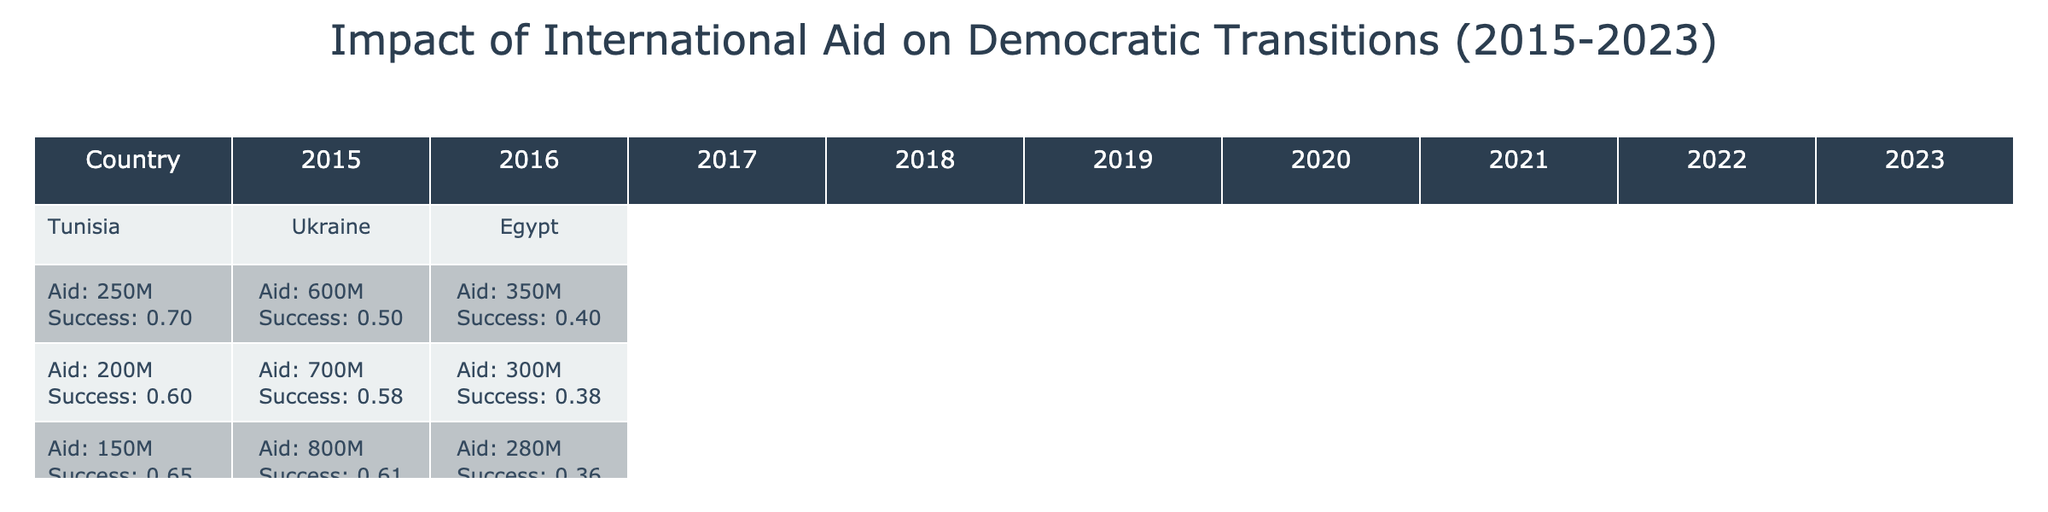What was the highest amount of international aid received by Tunisia between 2015 and 2023? In the table, looking at Tunisia's data, the highest amount of international aid was in 2021 with 350 million USD.
Answer: 350 million USD What was the Democratic Transition Success Index for Ukraine in 2022? The table shows that Ukraine's Democratic Transition Success Index for 2022 is 0.82.
Answer: 0.82 Did Egypt receive more international aid in 2015 than in 2022? From the table, Egypt received 350 million USD in 2015 and 150 million USD in 2022. Since 350 million is greater than 150 million, the answer is yes.
Answer: Yes Which country had the lowest Democratic Transition Success Index in 2019? Comparing the values for 2019, Tunisia has an index of 0.80, Ukraine has 0.67, and Egypt has 0.37. The country with the lowest index is Egypt at 0.37.
Answer: Egypt What is the total international aid received by Ukraine from 2015 to 2023? We can sum the international aid values for Ukraine from each year: 600 + 700 + 800 + 750 + 900 + 1000 + 1100 + 1200 + 1300 = 7050 million USD.
Answer: 7050 million USD How did the Democratic Transition Success Index for Egypt change from 2015 to 2023? In 2015, Egypt's index was 0.40, dropping to 0.28 in 2023. The change indicates a decline over the years.
Answer: Declined Was there a year where Tunisia had both the highest international aid and the highest success index? The highest international aid for Tunisia was in 2021 (350 million USD) with a success index of 0.81. Therefore, 2021 does not have the highest index, which was 0.85 in 2020 with different aid. The answer is no.
Answer: No What similar challenges did Ukraine face in 2020 and 2021, according to the table? Both years depict "COVID-19 isolation" for 2020 and "Political unrest" for 2021 as challenges. These are different challenges, so there is no overlap here. Thus, the answer is no.
Answer: No What was the average Democratic Transition Success Index for Tunisia over the years? We add Tunisia's indices: 0.7 + 0.6 + 0.65 + 0.74 + 0.8 + 0.85 + 0.81 + 0.78 + 0.75 = 6.57. To find the average, divide by the number of years (9): 6.57 / 9 = 0.73.
Answer: 0.73 